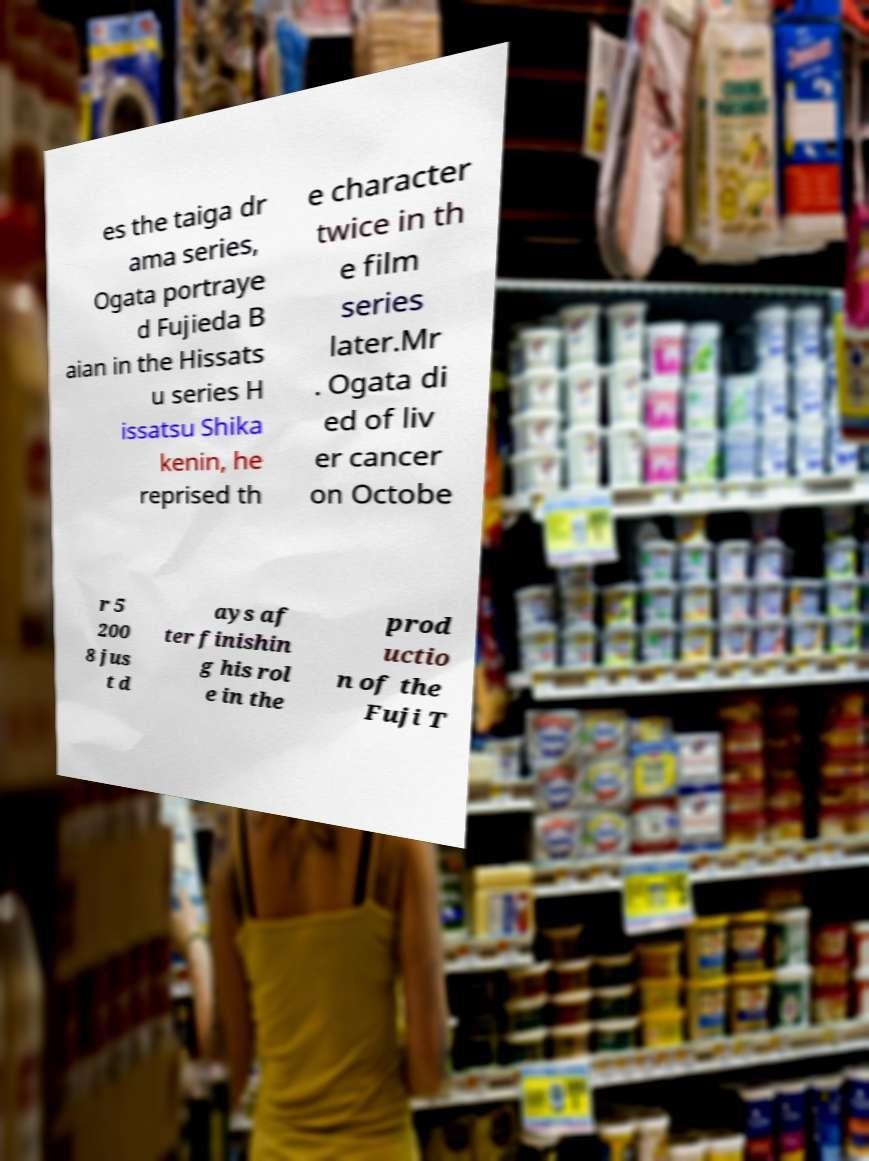There's text embedded in this image that I need extracted. Can you transcribe it verbatim? es the taiga dr ama series, Ogata portraye d Fujieda B aian in the Hissats u series H issatsu Shika kenin, he reprised th e character twice in th e film series later.Mr . Ogata di ed of liv er cancer on Octobe r 5 200 8 jus t d ays af ter finishin g his rol e in the prod uctio n of the Fuji T 